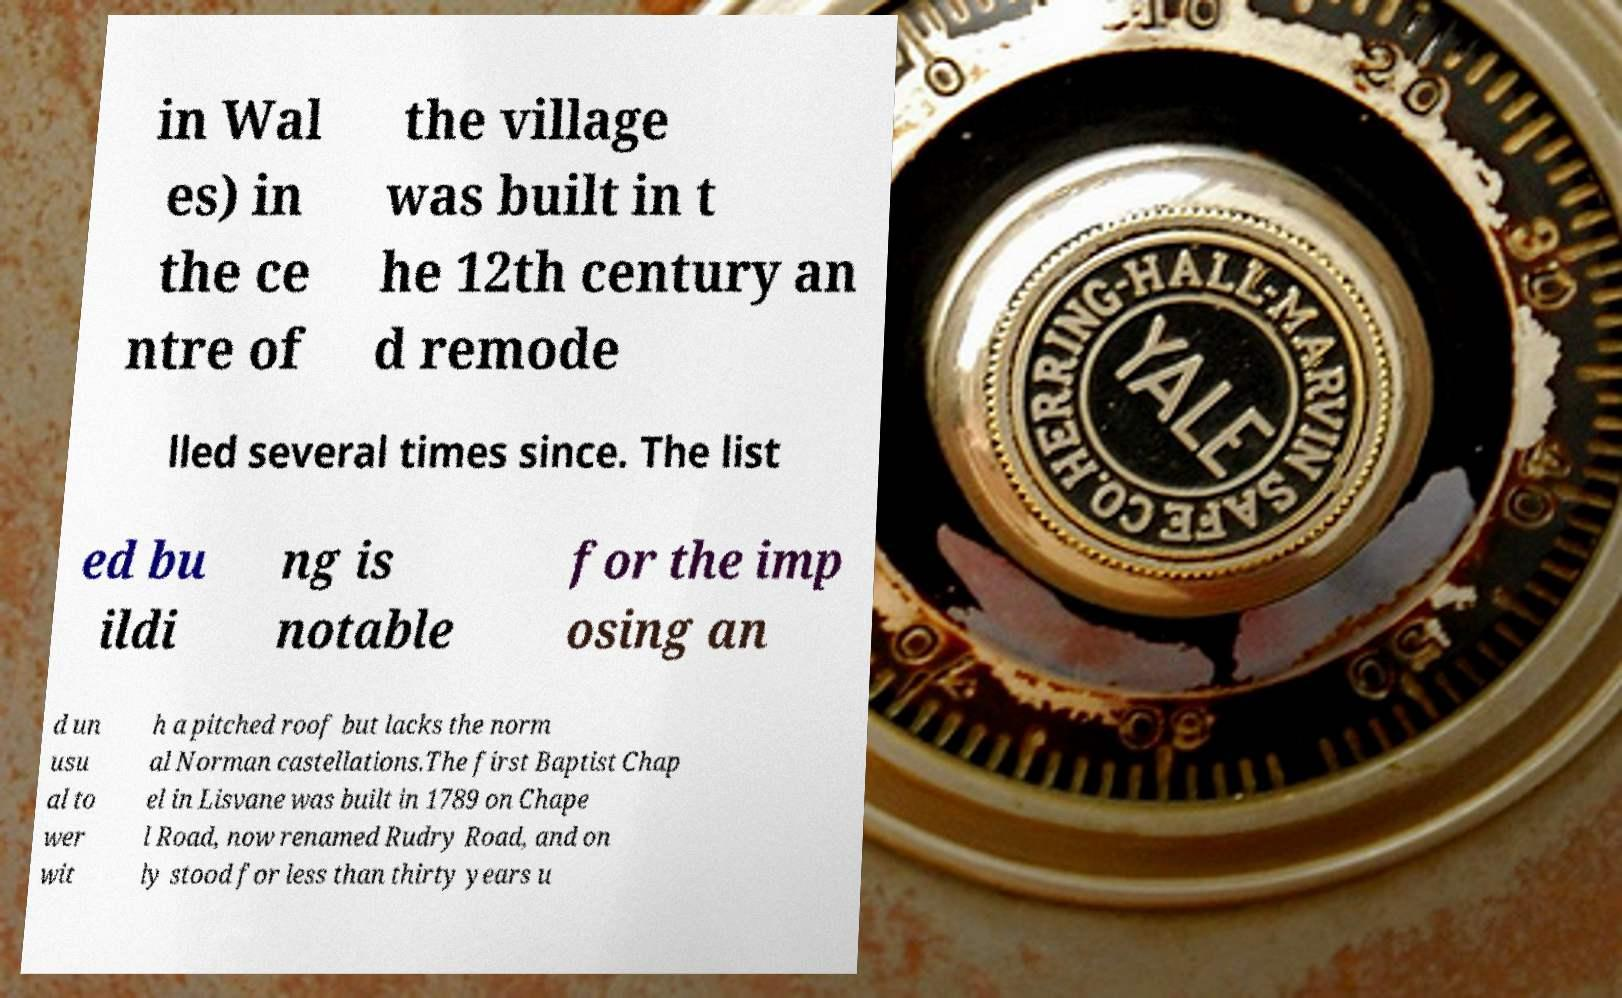There's text embedded in this image that I need extracted. Can you transcribe it verbatim? in Wal es) in the ce ntre of the village was built in t he 12th century an d remode lled several times since. The list ed bu ildi ng is notable for the imp osing an d un usu al to wer wit h a pitched roof but lacks the norm al Norman castellations.The first Baptist Chap el in Lisvane was built in 1789 on Chape l Road, now renamed Rudry Road, and on ly stood for less than thirty years u 